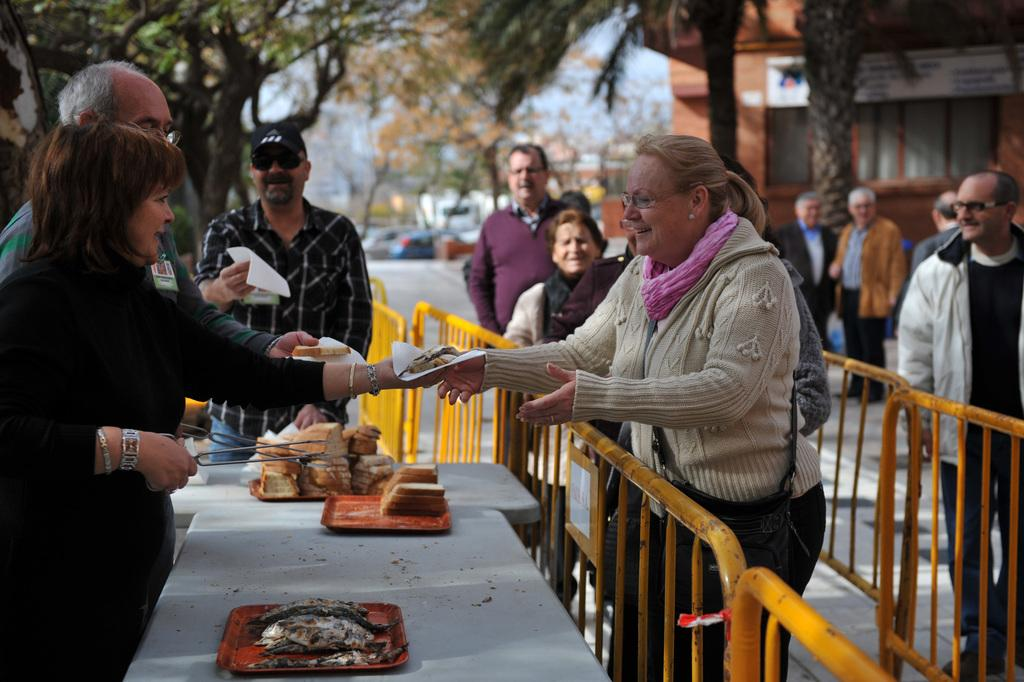What can be seen in the image involving people? There are people standing in the image. What is on the table in the image? There is food on the table and a tray. What can be seen in the background of the image? There are trees and a building in the background of the image. What is the price of the humor in the image? There is no humor or price mentioned in the image; it features people standing near a table with food and a tray, and trees and a building in the background. 